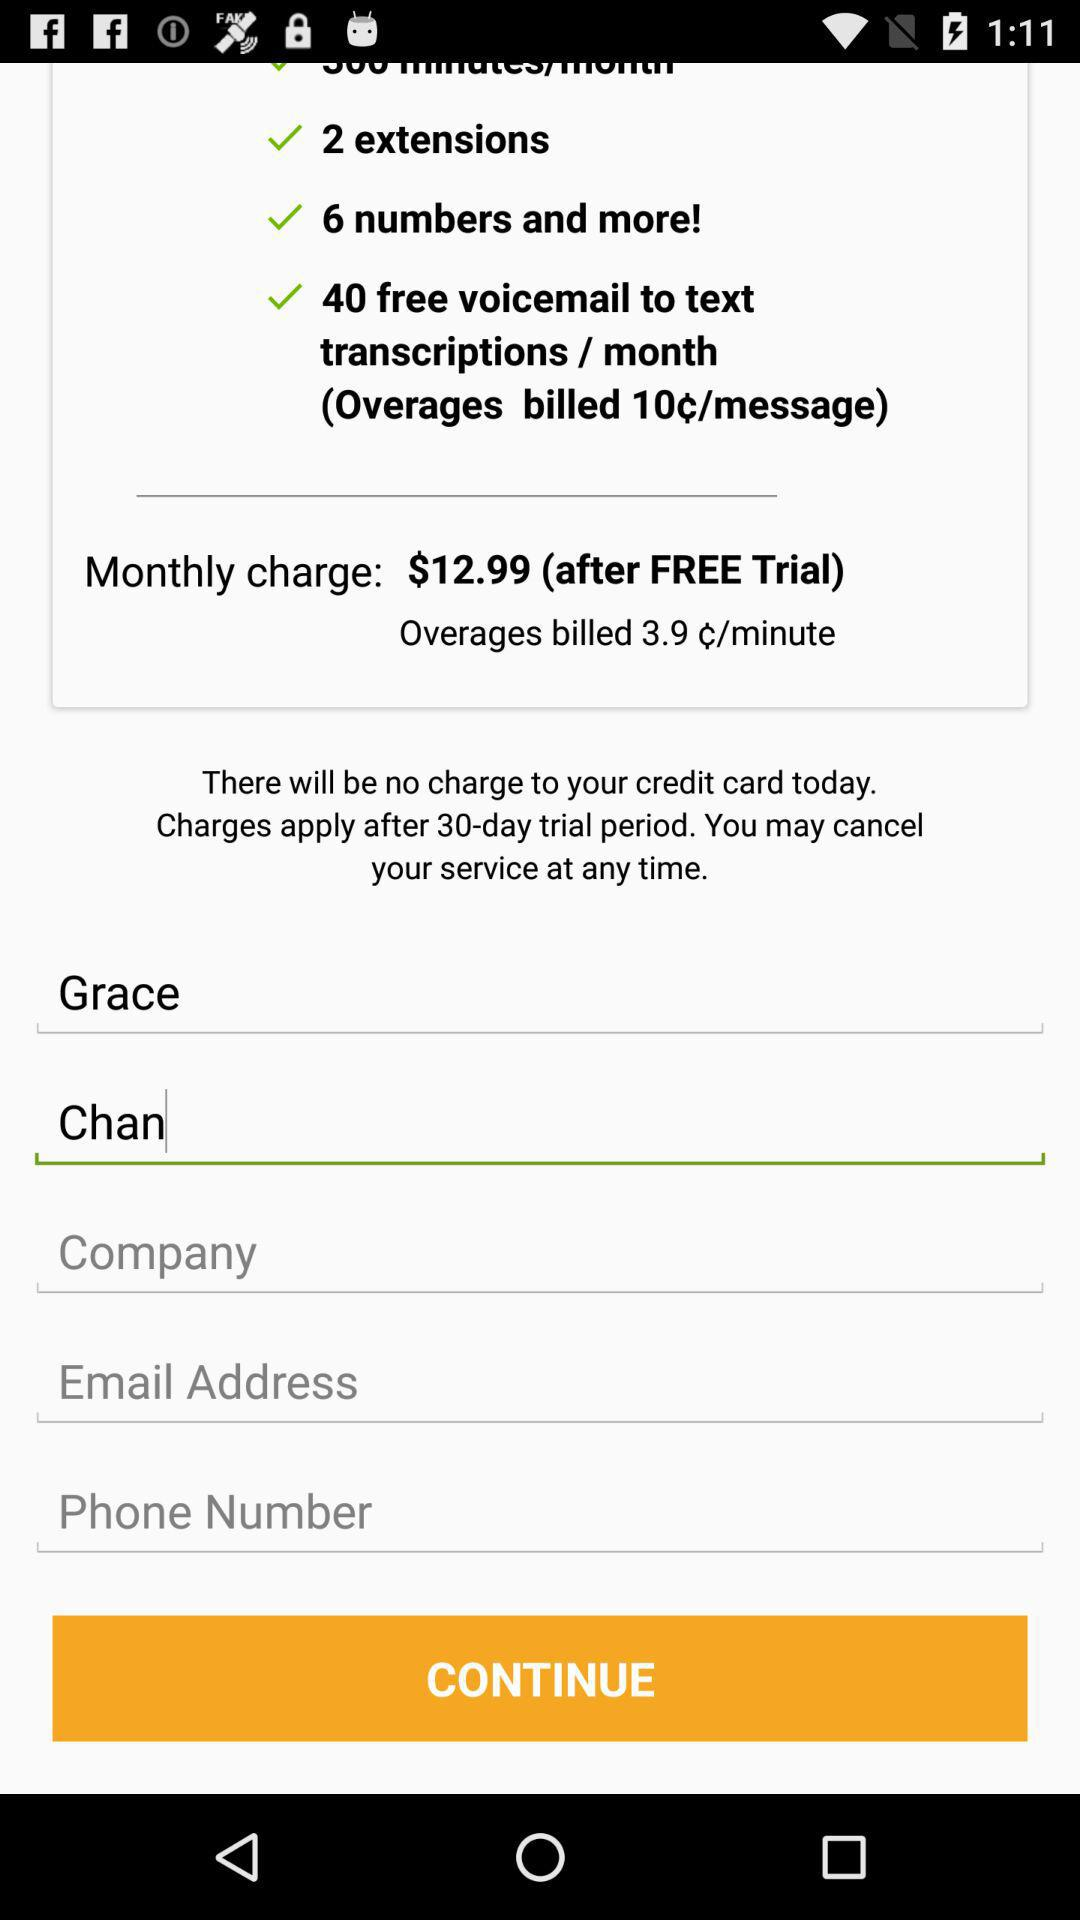What are the monthly charges after a free trial? The monthly charges after a free trial are $12.99. 